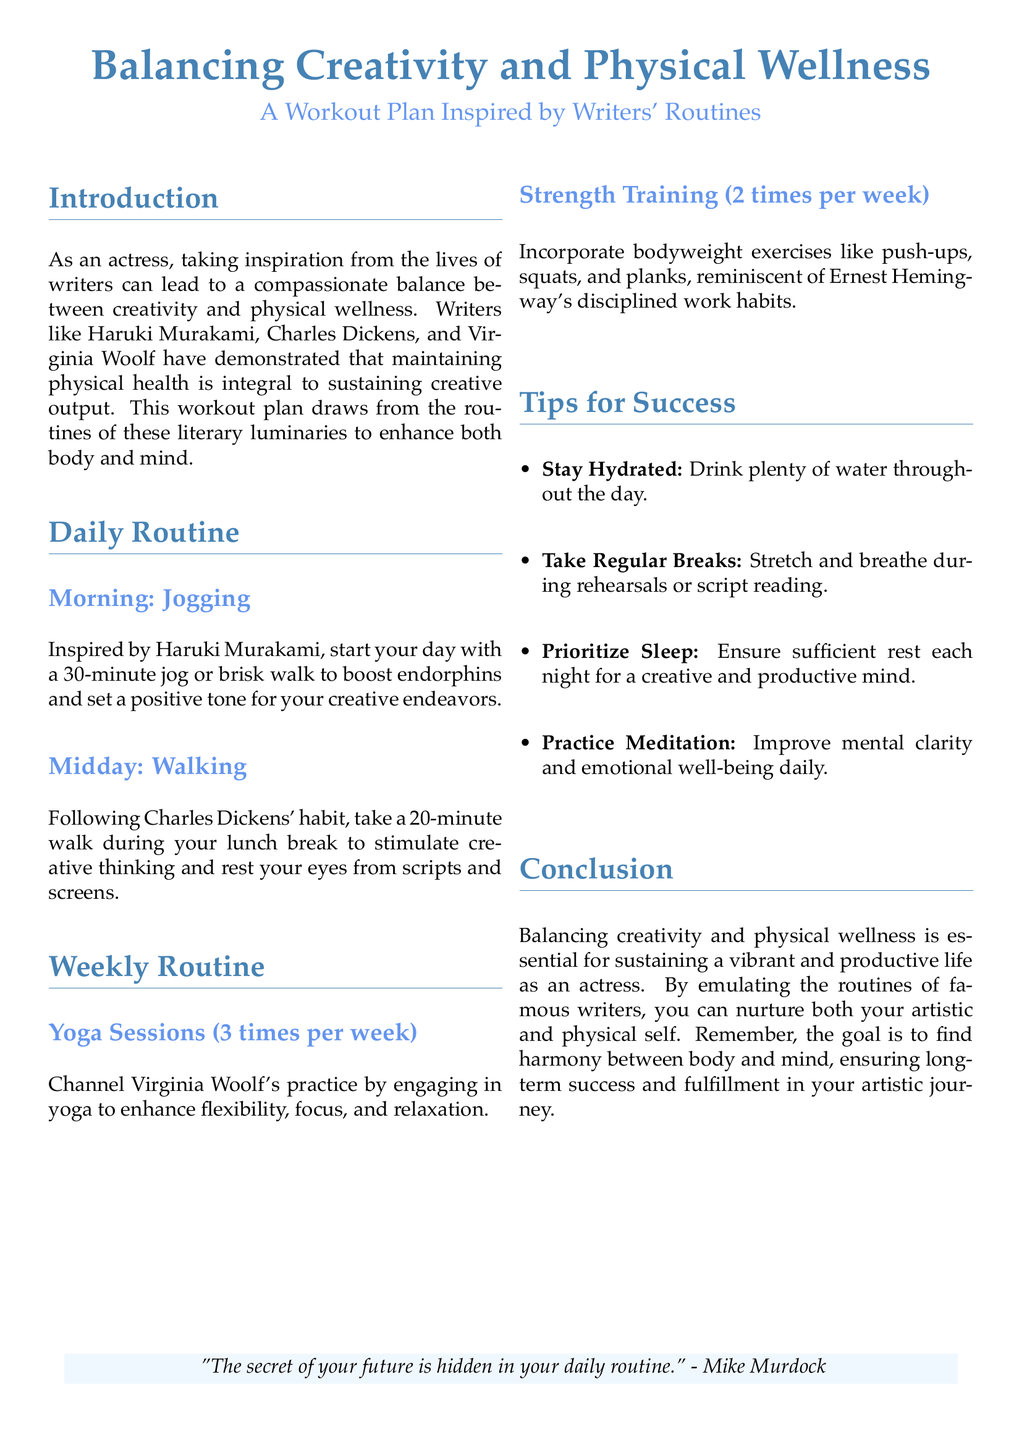What is the title of the document? The title is presented at the beginning of the document, highlighting the focus on creativity and physical wellness.
Answer: Balancing Creativity and Physical Wellness Who is the author of the yoga sessions mentioned? The yoga sessions are inspired by the practice of a renowned writer acknowledged in the document.
Answer: Virginia Woolf How long should the morning jog last? The duration of the morning jog is specified in the daily routine section.
Answer: 30 minutes How many times per week should strength training occur? The weekly routine outlines the frequency of strength training sessions.
Answer: 2 times What is the suggested time for the midday walk? The recommended duration for the midday walk is included in the document.
Answer: 20 minutes What is one benefit of practicing meditation according to the document? The document mentions one specific advantage of daily meditation in the tips for success section.
Answer: Improve mental clarity Which writer's disciplined work habits are referenced in the strength training section? The strength training motivation is linked to a specific author known for his disciplined routines.
Answer: Ernest Hemingway What color is used for the title of the document? The color used for the title is described in the formatting section at the beginning of the document.
Answer: RGB(70,130,180) What quote concludes the document? The document features a quote that encapsulates its message about daily routines at the end.
Answer: "The secret of your future is hidden in your daily routine." 